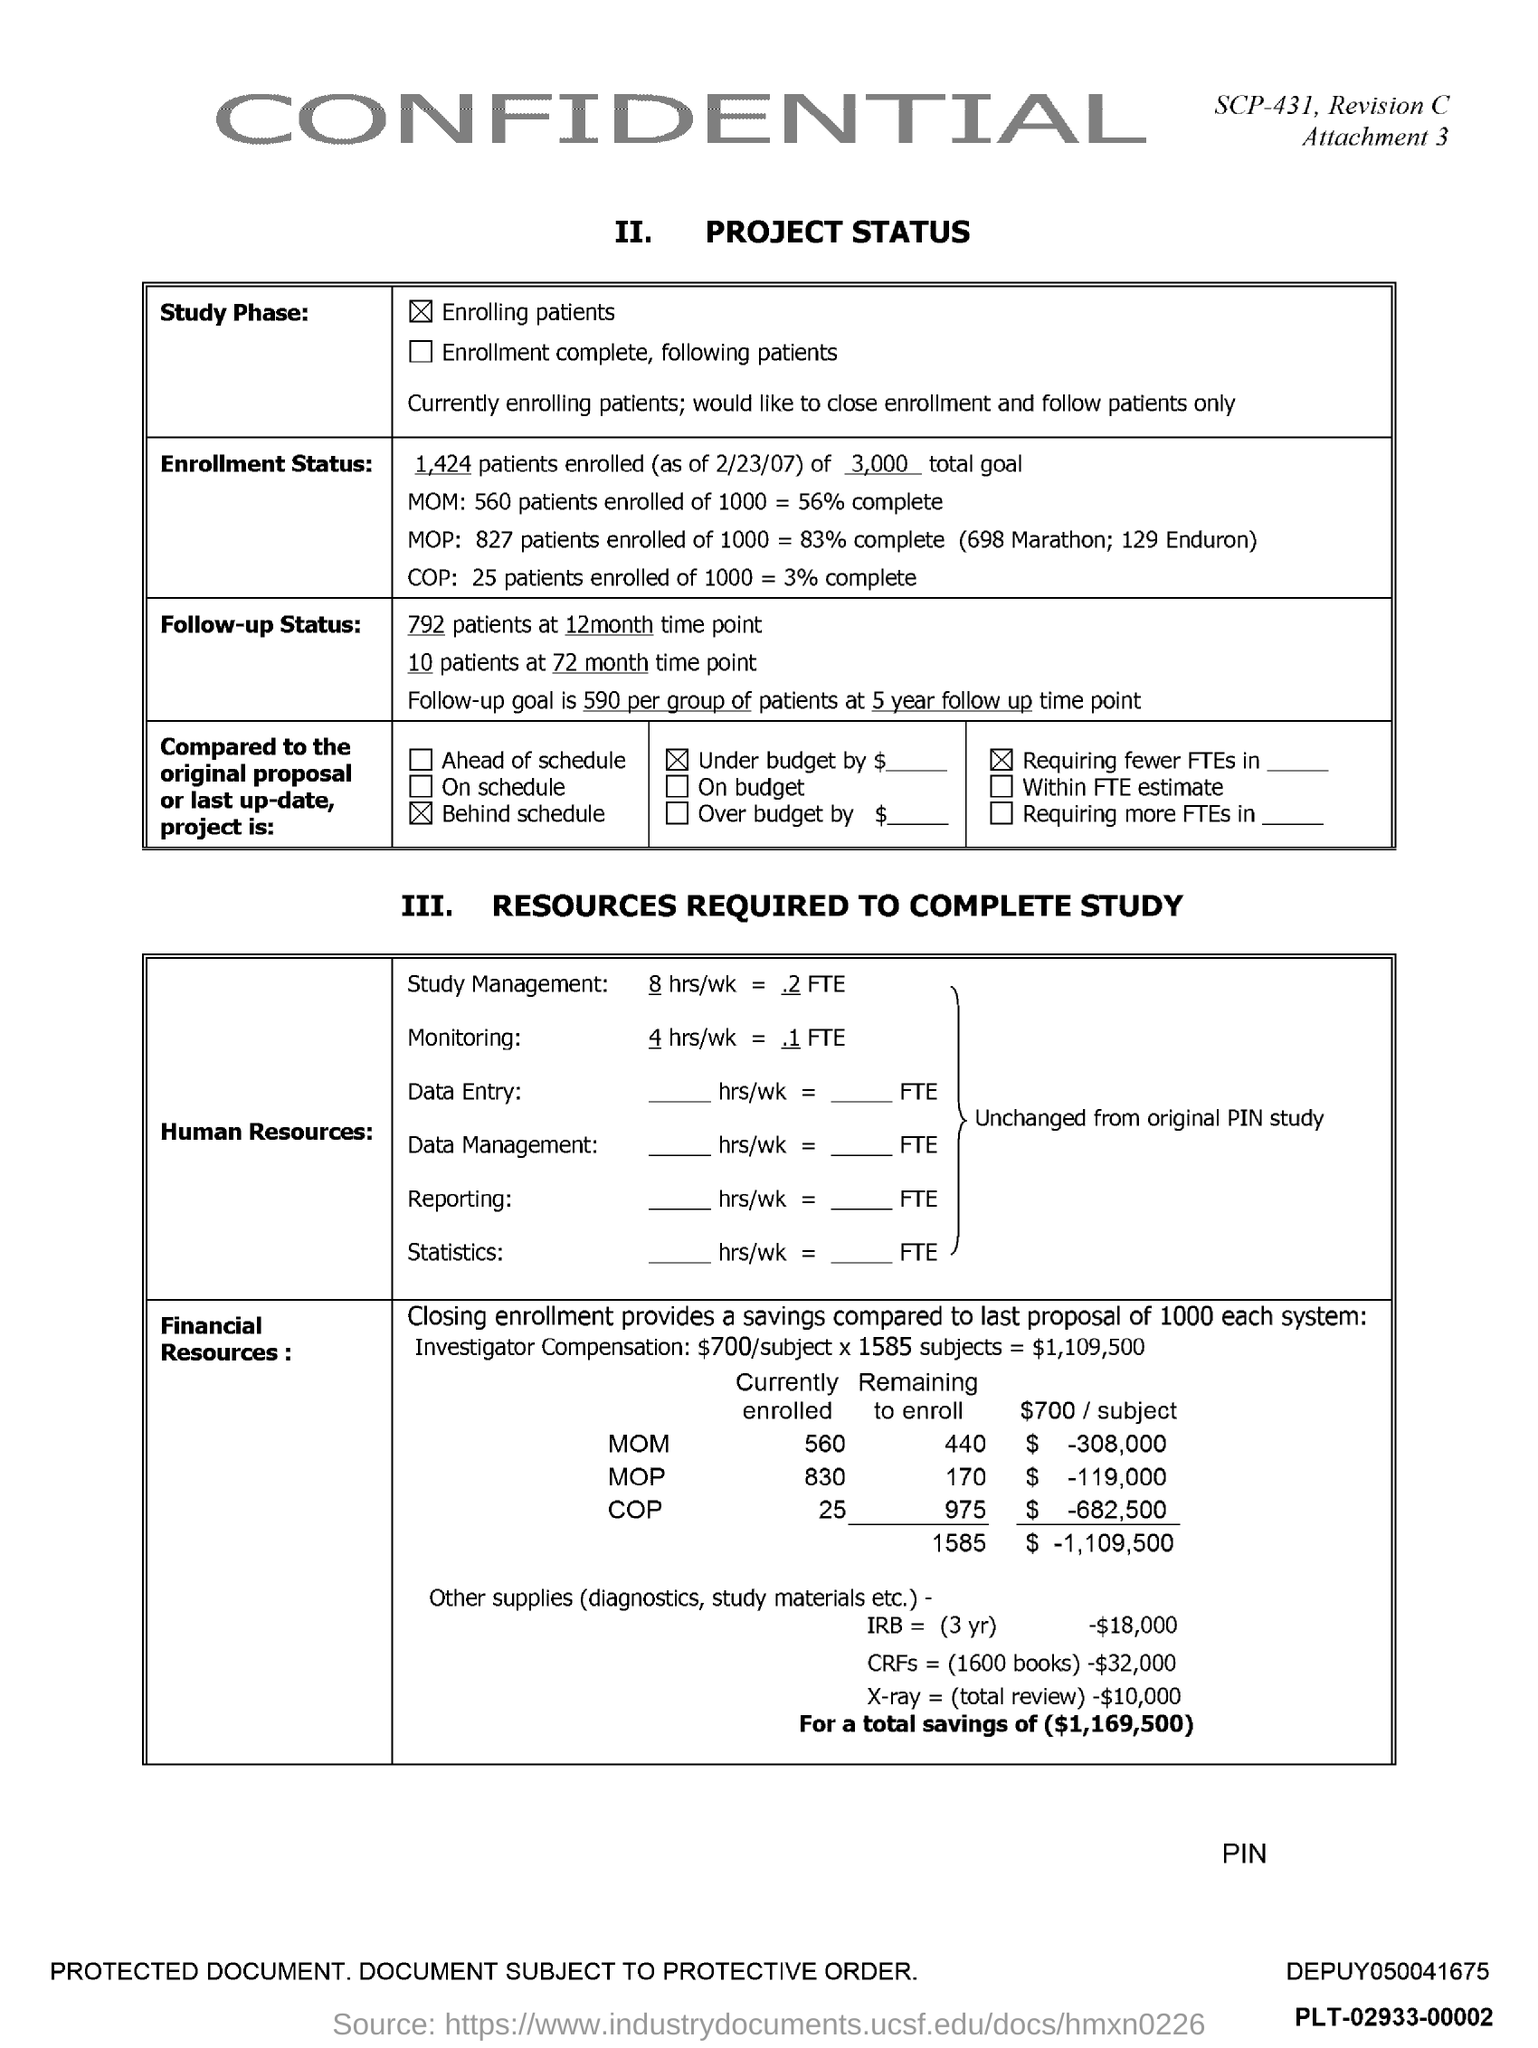Attachment Number mentioned in the document?
Keep it short and to the point. 3. 